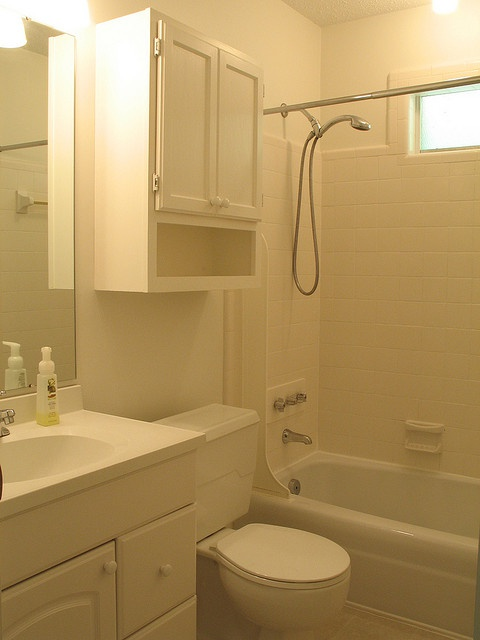Describe the objects in this image and their specific colors. I can see sink in white, olive, and tan tones, toilet in white, tan, and olive tones, and bottle in white, tan, and olive tones in this image. 